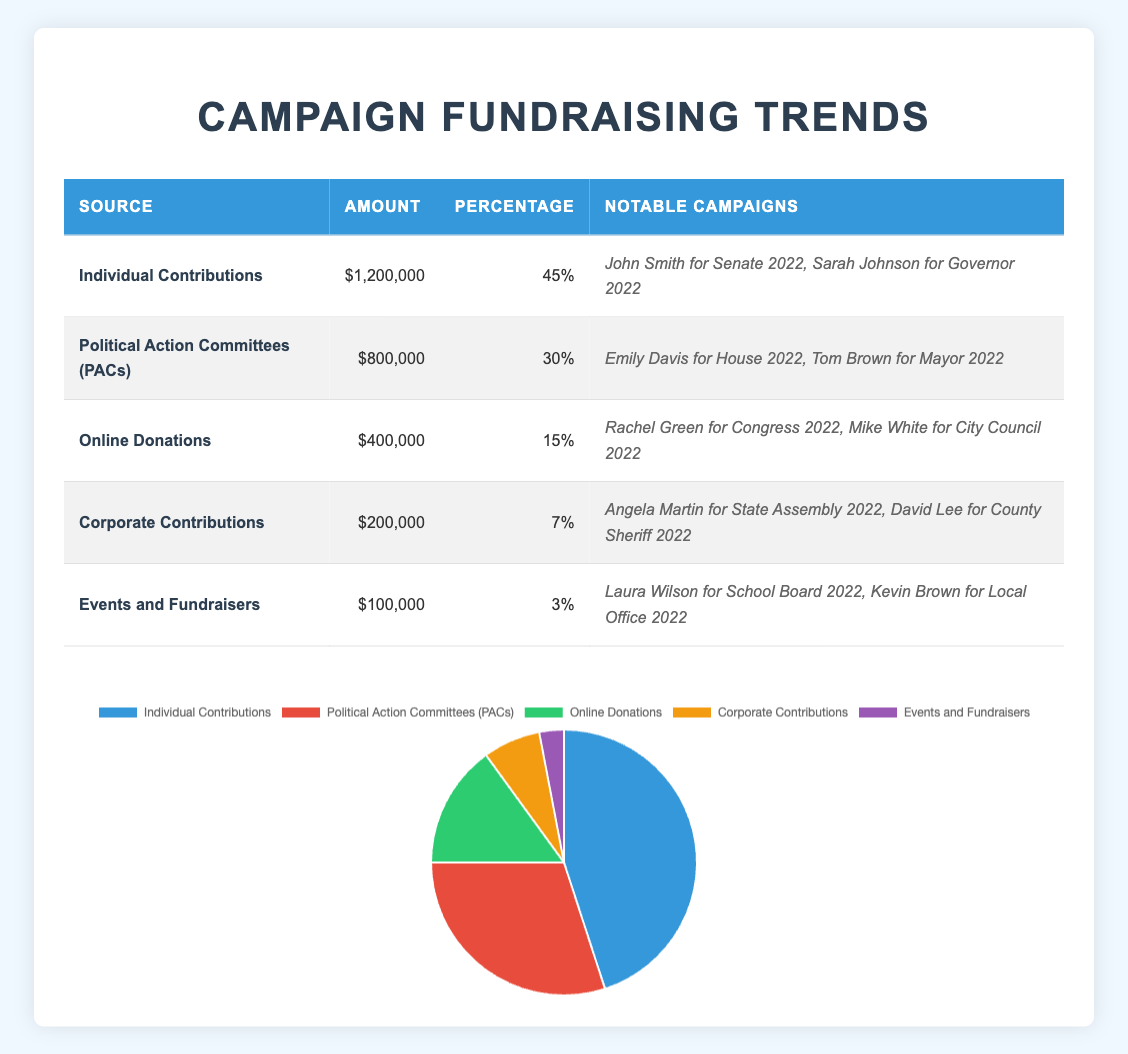What is the total amount raised from Individual Contributions? The table indicates that the amount raised from Individual Contributions is listed as $1,200,000.
Answer: $1,200,000 Which fundraising source has the highest percentage? According to the table, Individual Contributions hold the highest percentage at 45%.
Answer: Individual Contributions How much more did Political Action Committees (PACs) raise compared to Corporate Contributions? The amount raised by PACs is $800,000 and Corporate Contributions raised $200,000. The difference is $800,000 - $200,000 = $600,000.
Answer: $600,000 What percentage of total fundraising comes from Online Donations and Events and Fundraisers combined? Online Donations are 15% and Events and Fundraisers are 3%. Adding these together gives 15% + 3% = 18%.
Answer: 18% Is it true that Corporate Contributions raised less than Online Donations? The table shows Corporate Contributions raised $200,000, while Online Donations raised $400,000. This makes the statement true as $200,000 < $400,000.
Answer: Yes If the total amount raised from all fundraising sources is $2,400,000, what percentage do Events and Fundraisers represent? The amount raised from Events and Fundraisers is $100,000. To find the percentage, $100,000 / $2,400,000 x 100% = 4.17%, which can be rounded to 4%.
Answer: 4% What is the total amount raised from all fundraising sources? By adding the amounts from all sources: $1,200,000 + $800,000 + $400,000 + $200,000 + $100,000 = $2,700,000.
Answer: $2,700,000 Which fundraising source accounts for the smallest percentage? The table indicates that Events and Fundraisers account for only 3%, making it the smallest percentage.
Answer: Events and Fundraisers 